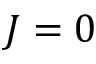<formula> <loc_0><loc_0><loc_500><loc_500>J = 0</formula> 